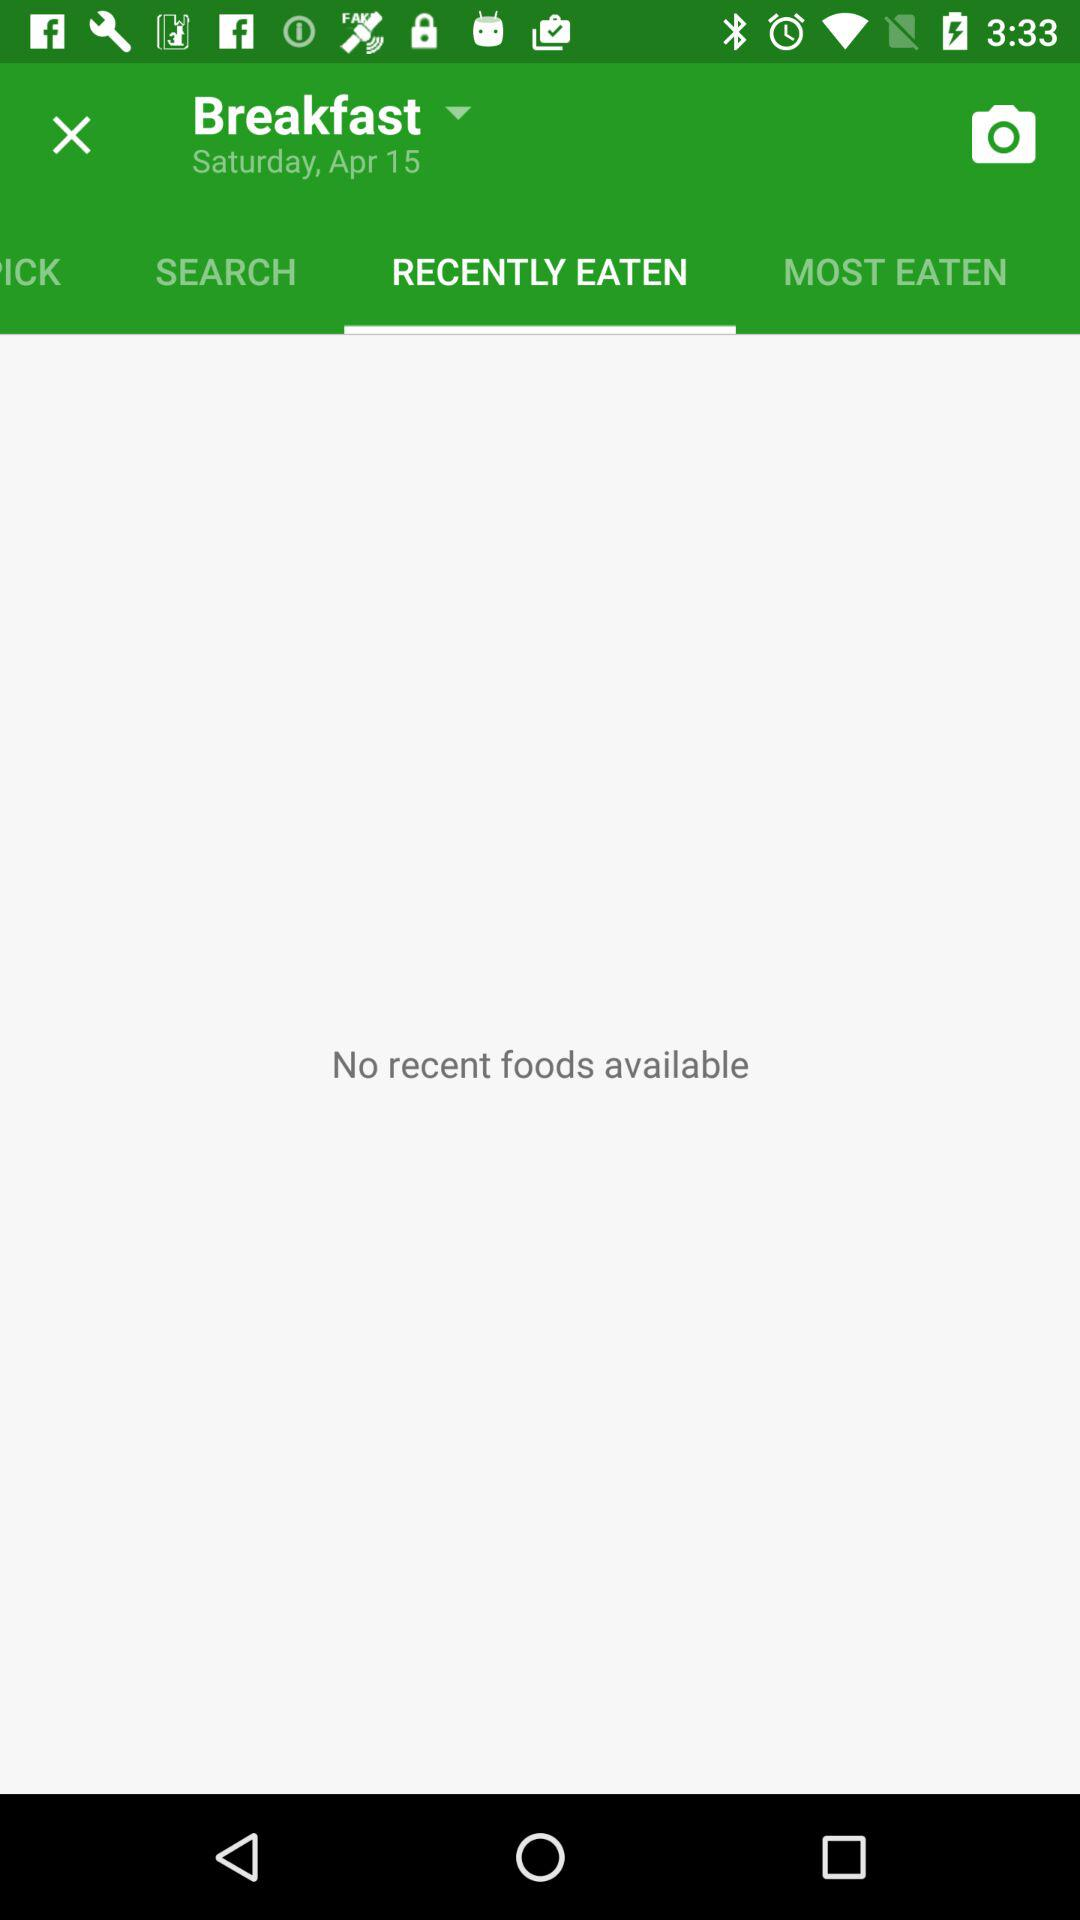Which day is on 13 April?
When the provided information is insufficient, respond with <no answer>. <no answer> 